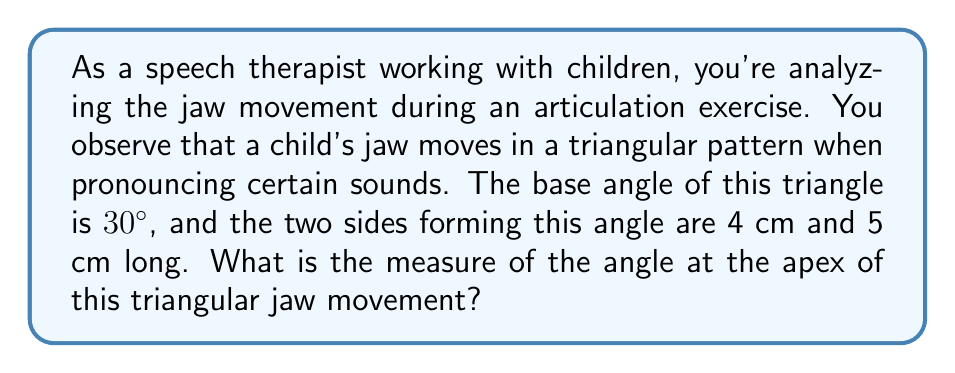Can you solve this math problem? To solve this problem, we can use the law of cosines, which relates the cosine of an angle to the lengths of the sides in a triangle. Let's approach this step-by-step:

1) Let's denote the apex angle as $\theta$. We need to find this angle.

2) We know:
   - One base angle is 30°
   - The two sides forming this angle are 4 cm and 5 cm
   - Let's call the third side (opposite to the 30° angle) $c$

3) The law of cosines states:
   $c^2 = a^2 + b^2 - 2ab \cos(C)$
   where $C$ is the angle opposite to side $c$

4) In our case:
   $c^2 = 4^2 + 5^2 - 2(4)(5) \cos(30°)$

5) Let's calculate:
   $c^2 = 16 + 25 - 40 \cos(30°)$
   $c^2 = 41 - 40(0.866)$ (as $\cos(30°) = \frac{\sqrt{3}}{2} \approx 0.866$)
   $c^2 = 41 - 34.64 = 6.36$
   $c = \sqrt{6.36} \approx 2.52$ cm

6) Now we know all three sides of the triangle: 4 cm, 5 cm, and 2.52 cm

7) We can use the law of cosines again to find the apex angle $\theta$:
   $2.52^2 = 4^2 + 5^2 - 2(4)(5) \cos(\theta)$

8) Solving for $\cos(\theta)$:
   $6.3504 = 16 + 25 - 40 \cos(\theta)$
   $40 \cos(\theta) = 41 - 6.3504 = 34.6496$
   $\cos(\theta) = \frac{34.6496}{40} = 0.8662$

9) Therefore:
   $\theta = \arccos(0.8662) \approx 30°$

10) The other base angle must also be 30° (as the sum of angles in a triangle is 180°)

[asy]
import geometry;

size(200);

pair A = (0,0), B = (4,0), C = (2.5,2.17);

draw(A--B--C--A);

label("4 cm", (A+B)/2, S);
label("5 cm", (B+C)/2, NE);
label("2.52 cm", (A+C)/2, NW);

label("30°", A, SW);
label("30°", B, SE);
label("θ ≈ 120°", C, N);

dot("A", A, SW);
dot("B", B, SE);
dot("C", C, N);
[/asy]
Answer: The measure of the angle at the apex of the triangular jaw movement is approximately $120°$. 